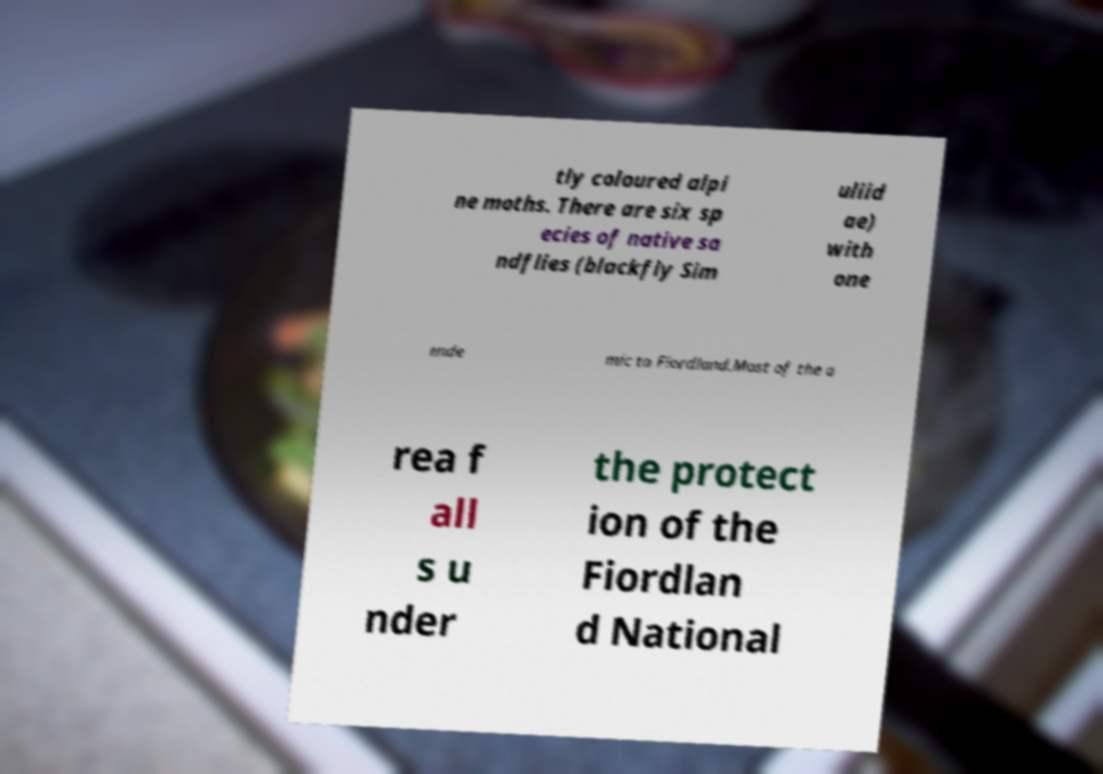Can you accurately transcribe the text from the provided image for me? tly coloured alpi ne moths. There are six sp ecies of native sa ndflies (blackfly Sim uliid ae) with one ende mic to Fiordland.Most of the a rea f all s u nder the protect ion of the Fiordlan d National 